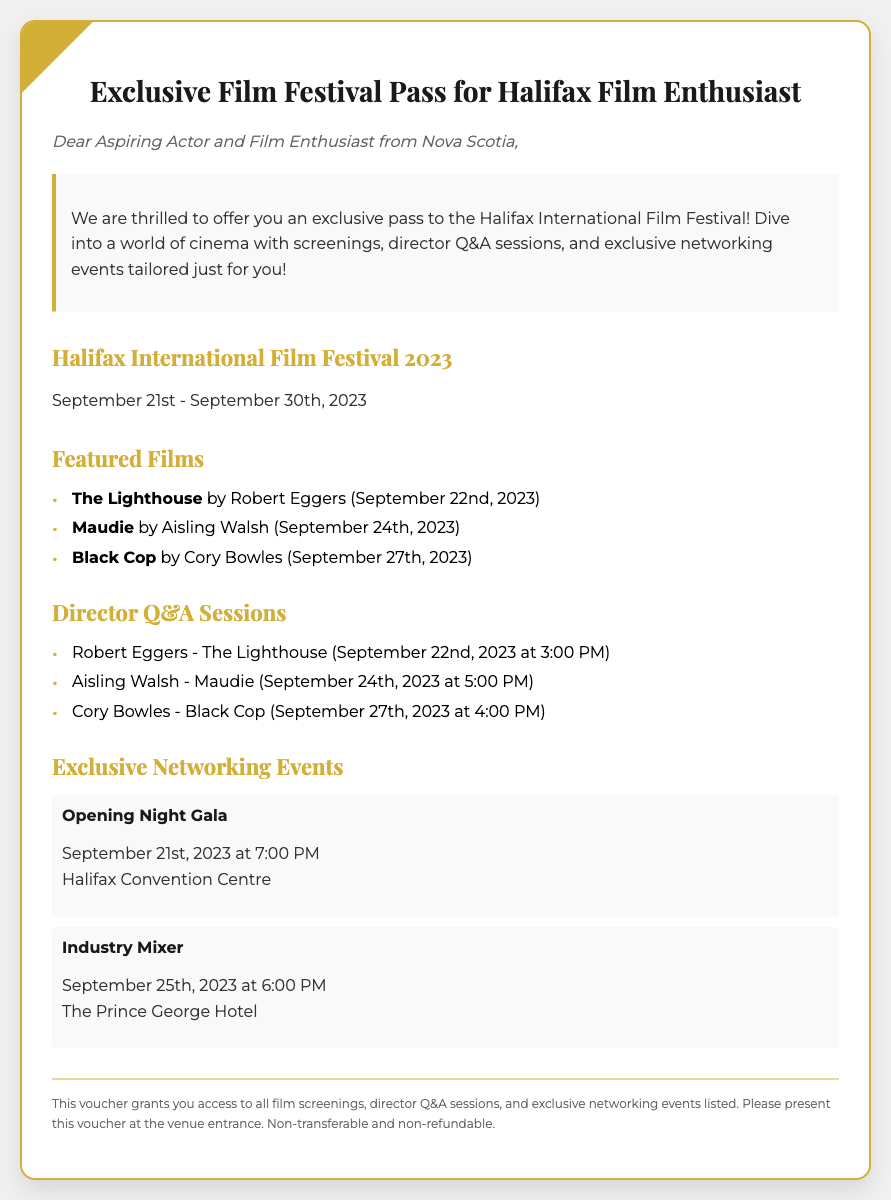What are the festival dates? The festival dates are specified in the document as September 21st - September 30th, 2023.
Answer: September 21st - September 30th, 2023 Who is the director of "The Lighthouse"? The director of "The Lighthouse" is mentioned in the document as Robert Eggers.
Answer: Robert Eggers What time is the Q&A session for "Maudie"? The document states that the Q&A session for "Maudie" is at 5:00 PM on September 24th, 2023.
Answer: 5:00 PM What is the venue for the Opening Night Gala? The venue for the Opening Night Gala is noted in the document as Halifax Convention Centre.
Answer: Halifax Convention Centre How many featured films are listed? The document lists three featured films as part of the film festival.
Answer: Three What does this voucher grant access to? The document specifies that the voucher grants access to all film screenings, director Q&A sessions, and exclusive networking events listed.
Answer: All film screenings, director Q&A sessions, and exclusive networking events When is the Industry Mixer scheduled? According to the document, the Industry Mixer is scheduled for September 25th, 2023 at 6:00 PM.
Answer: September 25th, 2023 at 6:00 PM Is the voucher transferable? The document clearly states that the voucher is non-transferable.
Answer: Non-transferable 